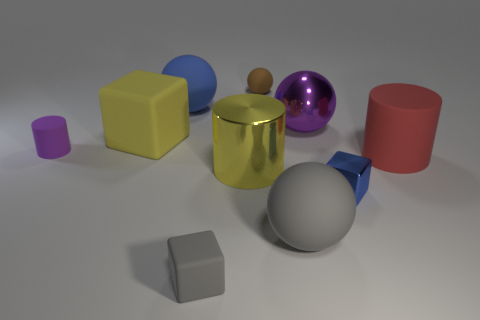How many things are the same color as the big metal ball?
Your answer should be very brief. 1. How many objects are purple objects in front of the yellow block or gray metallic cylinders?
Offer a very short reply. 1. What number of objects are both to the right of the small purple rubber thing and in front of the blue matte ball?
Offer a very short reply. 7. How many things are rubber objects that are in front of the small blue object or small objects that are in front of the small cylinder?
Offer a terse response. 3. How many other things are there of the same shape as the large gray object?
Ensure brevity in your answer.  3. Is the color of the rubber ball that is left of the tiny gray matte thing the same as the tiny metallic block?
Make the answer very short. Yes. How many other objects are there of the same size as the blue metallic object?
Your response must be concise. 3. Is the tiny ball made of the same material as the yellow cube?
Provide a succinct answer. Yes. There is a large rubber sphere that is behind the yellow object that is in front of the big yellow matte thing; what is its color?
Make the answer very short. Blue. There is a yellow object that is the same shape as the large red rubber object; what is its size?
Your answer should be very brief. Large. 